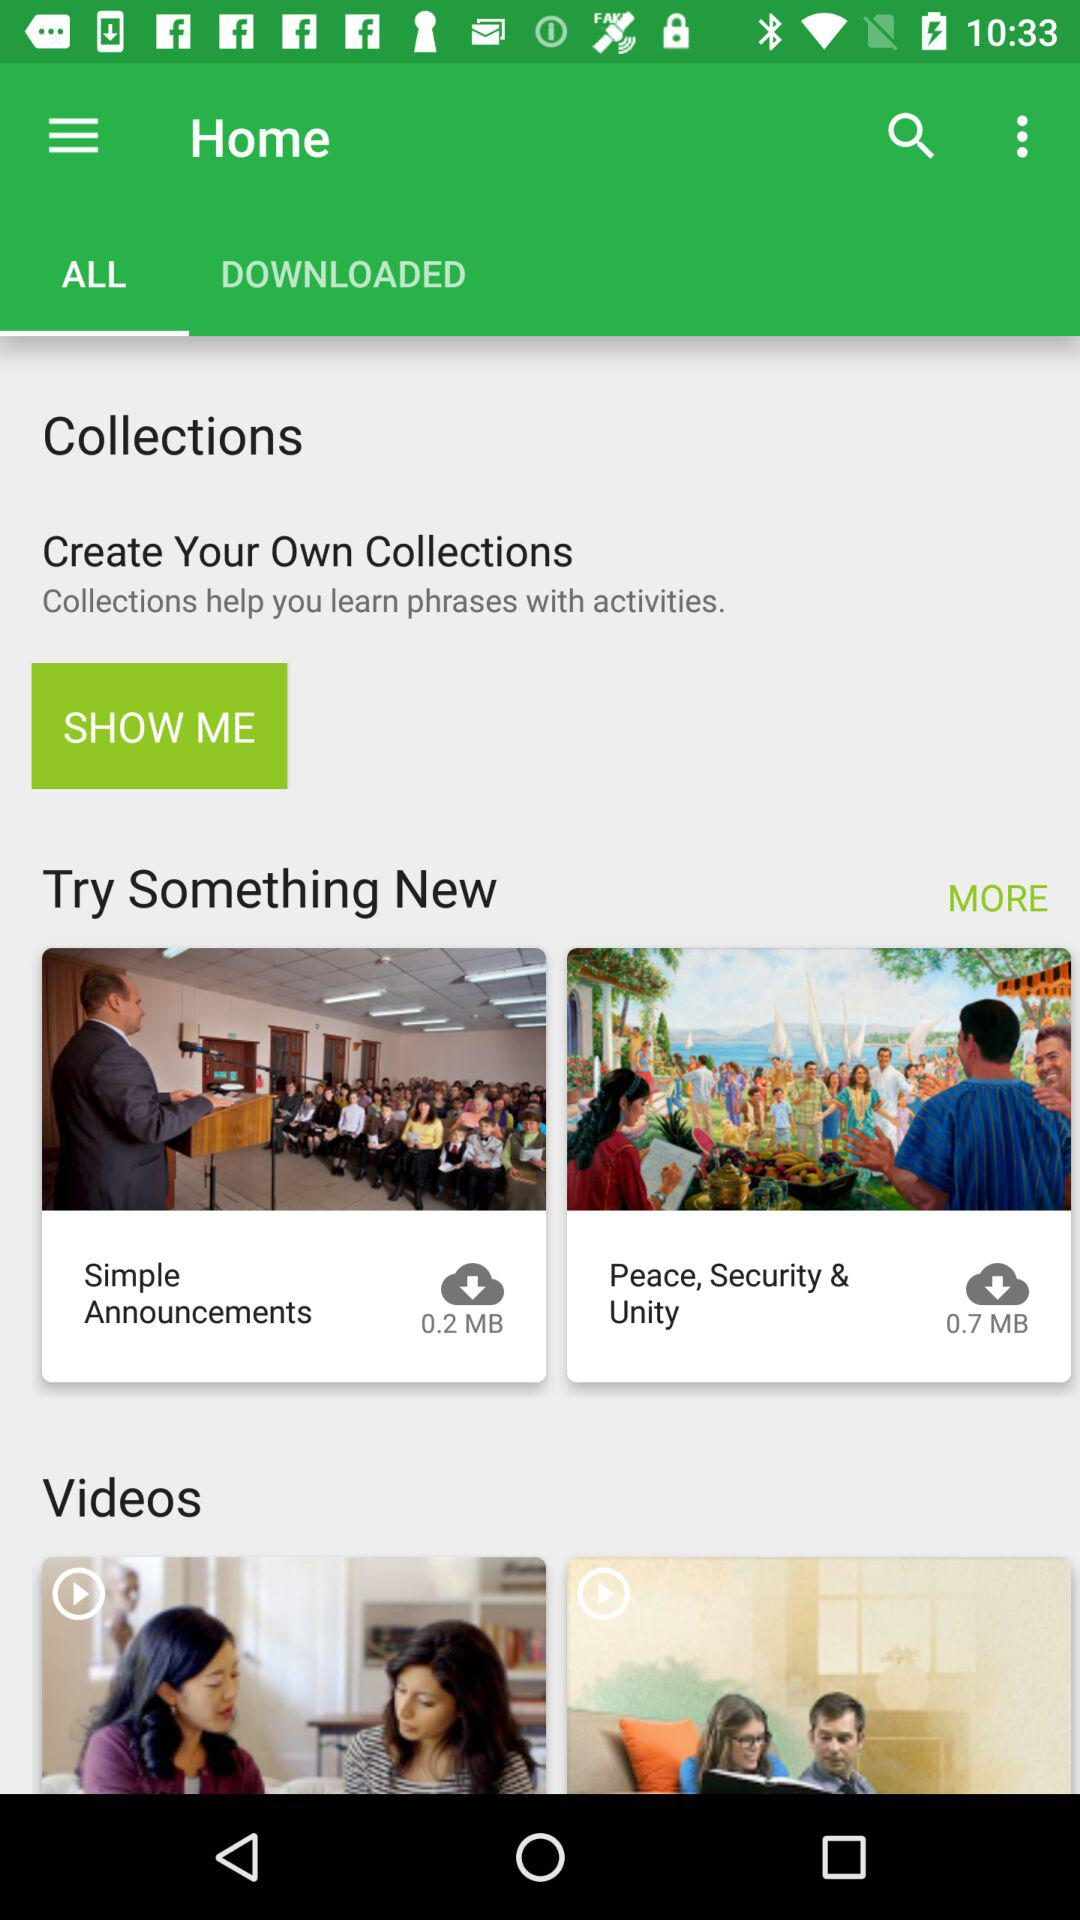How many more MB of data does the 'Peace, Security & Unity' collection use than the 'Simple Announcements' collection?
Answer the question using a single word or phrase. 0.5 